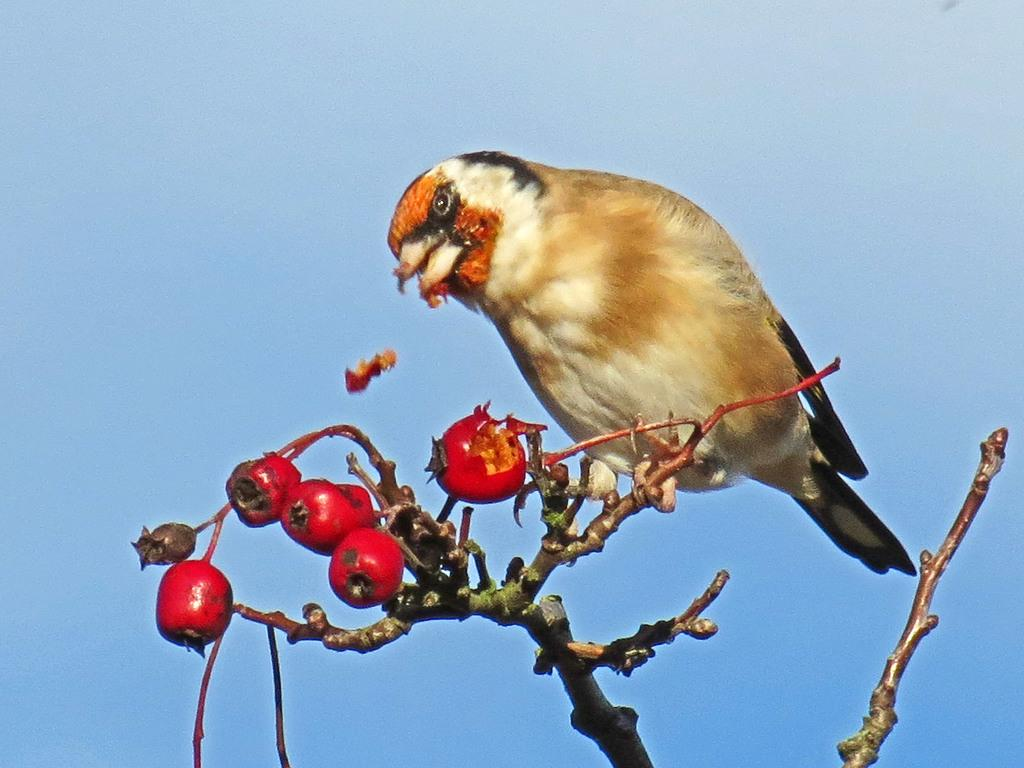What animal can be seen in the image? There is a bird on a branch in the image. What else is present in the image besides the bird? Fruits are visible in the image. What is the color of the sky in the image? The sky is blue in the image. What type of pie is being served at the event in the image? There is no event or pie present in the image; it features a bird on a branch and fruits. 